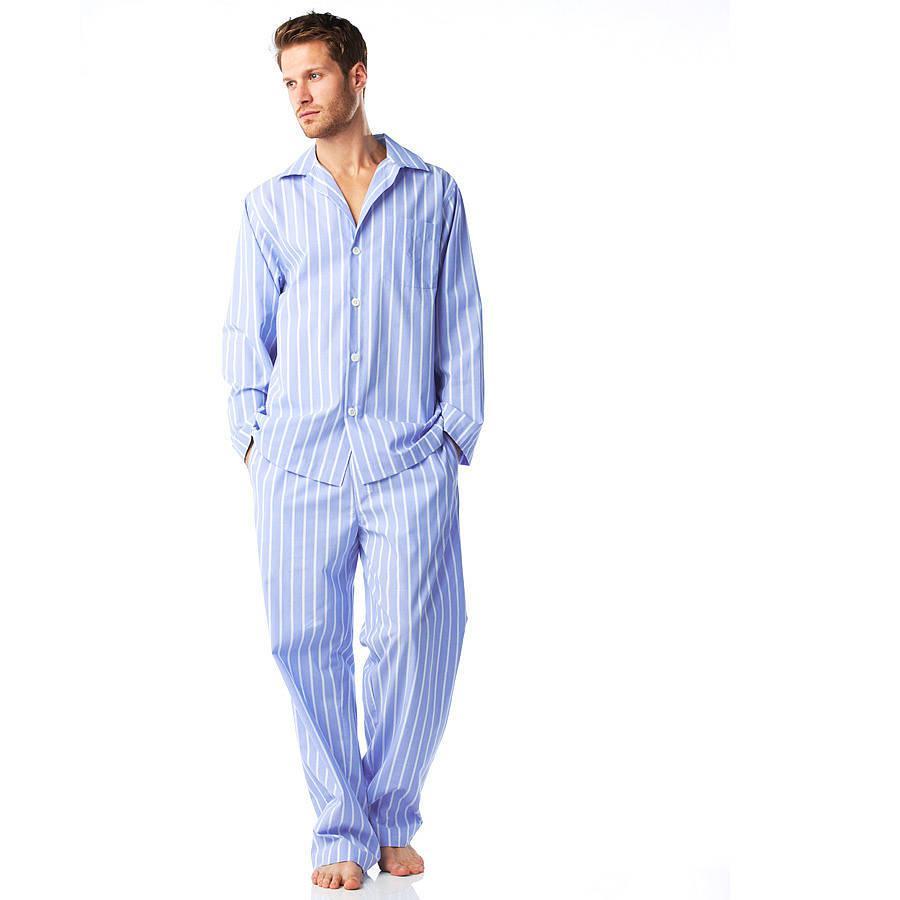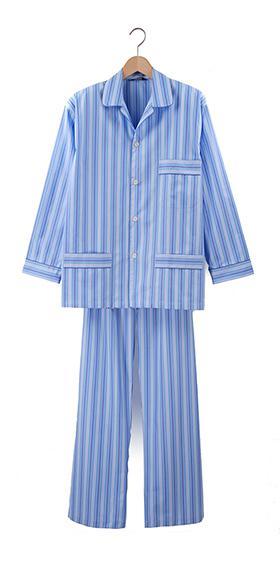The first image is the image on the left, the second image is the image on the right. Analyze the images presented: Is the assertion "An image shows two overlapping sleep outfits that are not worn by models or mannequins." valid? Answer yes or no. No. The first image is the image on the left, the second image is the image on the right. For the images displayed, is the sentence "One pair of men's blue pajamas with long sleeves is worn by a model, while a second pair is displayed on a hanger." factually correct? Answer yes or no. Yes. 